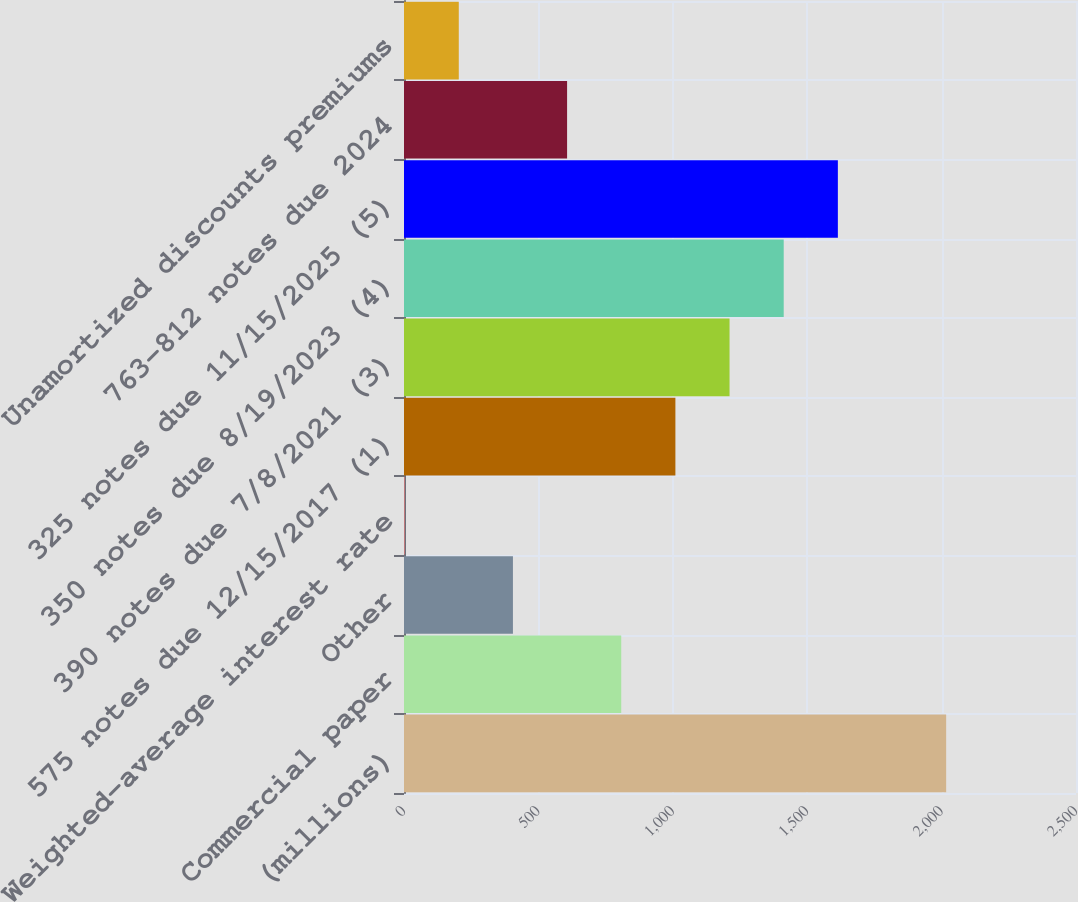Convert chart to OTSL. <chart><loc_0><loc_0><loc_500><loc_500><bar_chart><fcel>(millions)<fcel>Commercial paper<fcel>Other<fcel>Weighted-average interest rate<fcel>575 notes due 12/15/2017 (1)<fcel>390 notes due 7/8/2021 (3)<fcel>350 notes due 8/19/2023 (4)<fcel>325 notes due 11/15/2025 (5)<fcel>763-812 notes due 2024<fcel>Unamortized discounts premiums<nl><fcel>2017<fcel>808.18<fcel>405.24<fcel>2.3<fcel>1009.65<fcel>1211.12<fcel>1412.59<fcel>1614.06<fcel>606.71<fcel>203.77<nl></chart> 